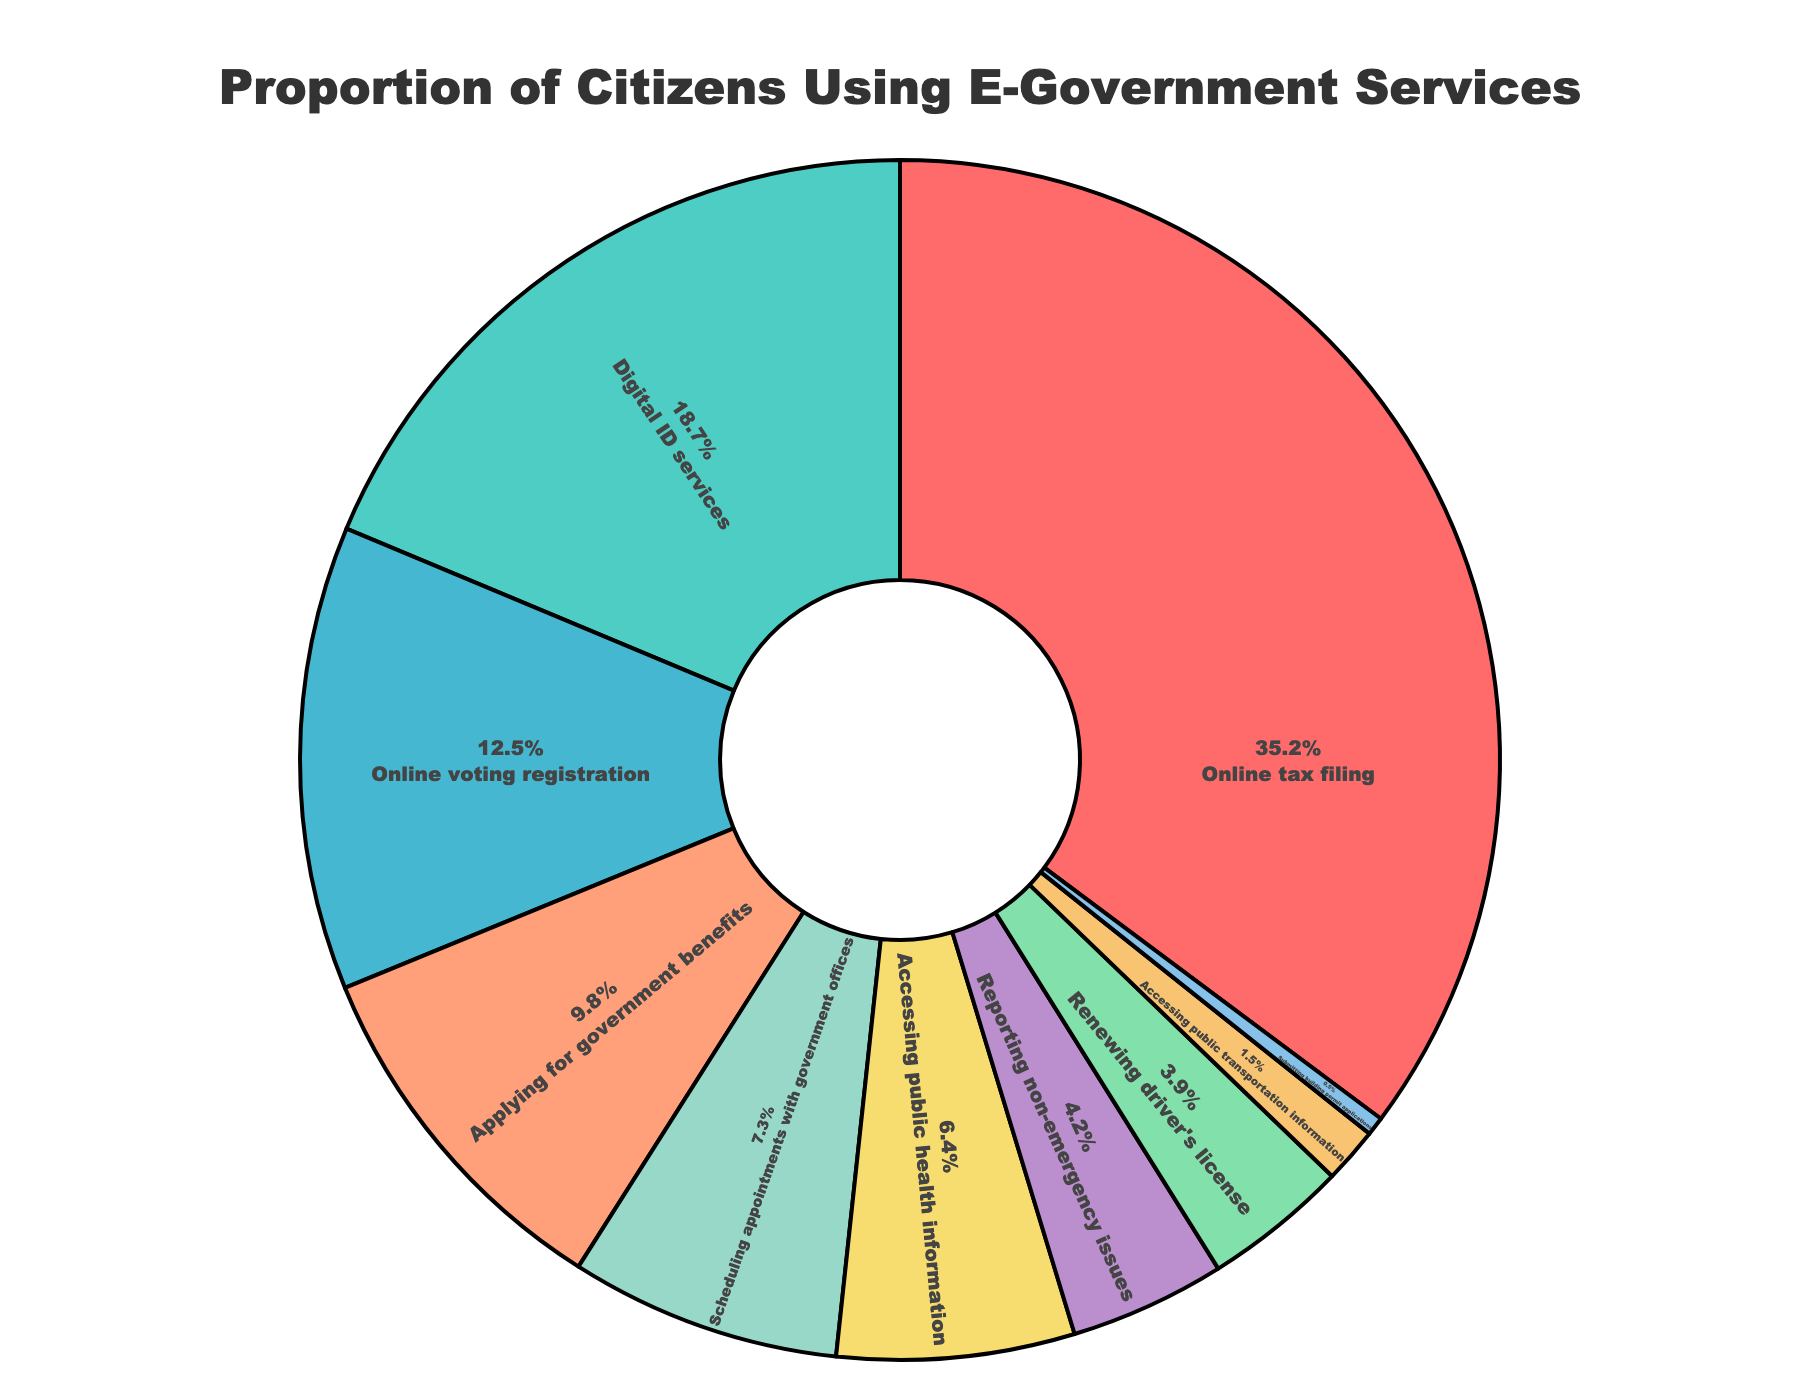What percentage of citizens use online tax filing services? Look at the pie chart and locate the segment labeled "Online tax filing". The percentage shown inside that segment is 35.2%.
Answer: 35.2% Which e-government service is the least used by citizens? Identify the smallest segment in the pie chart. The segment labeled "Submitting building permit applications" has the smallest percentage of 0.5%.
Answer: Submitting building permit applications How many more citizens use digital ID services than accessing public health information? Compare the percentages for "Digital ID services" (18.7%) and "Accessing public health information" (6.4%). Subtract the smaller percentage from the larger one (18.7% - 6.4% = 12.3%).
Answer: 12.3% What is the combined percentage of citizens using online voting registration and reporting non-emergency issues? Locate the segments for "Online voting registration" and "Reporting non-emergency issues." Add their percentages (12.5% + 4.2% = 16.7%).
Answer: 16.7% Which has a higher usage: scheduling appointments with government offices or renewing driver's license? Identify the segments for "Scheduling appointments with government offices" (7.3%) and "Renewing driver's license" (3.9%). Compare their percentages; 7.3% is greater than 3.9%.
Answer: Scheduling appointments with government offices What is the difference in the percentage of citizens applying for government benefits and accessing public transportation information? Compare the percentages of the two segments: "Applying for government benefits" (9.8%) and "Accessing public transportation information" (1.5%). Subtract the smaller percentage from the larger one (9.8% - 1.5% = 8.3%).
Answer: 8.3% What is the total percentage of citizens using either online tax filing or applying for government benefits? Sum the percentages of "Online tax filing" (35.2%) and "Applying for government benefits" (9.8%). The total percentage is 35.2% + 9.8% = 45%.
Answer: 45% Which segment is represented in light red color in the pie chart? Visually identify the segments based on color. The light red segment corresponds to "Online tax filing".
Answer: Online tax filing How many times more citizens use online tax filing compared to submitting building permit applications? Compare the percentages: "Online tax filing" (35.2%) and "Submitting building permit applications" (0.5%). Divide the larger percentage by the smaller one (35.2 / 0.5 = 70.4).
Answer: 70.4 times 